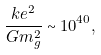<formula> <loc_0><loc_0><loc_500><loc_500>\frac { k e ^ { 2 } } { G m _ { g } ^ { 2 } } \sim 1 0 ^ { 4 0 } ,</formula> 